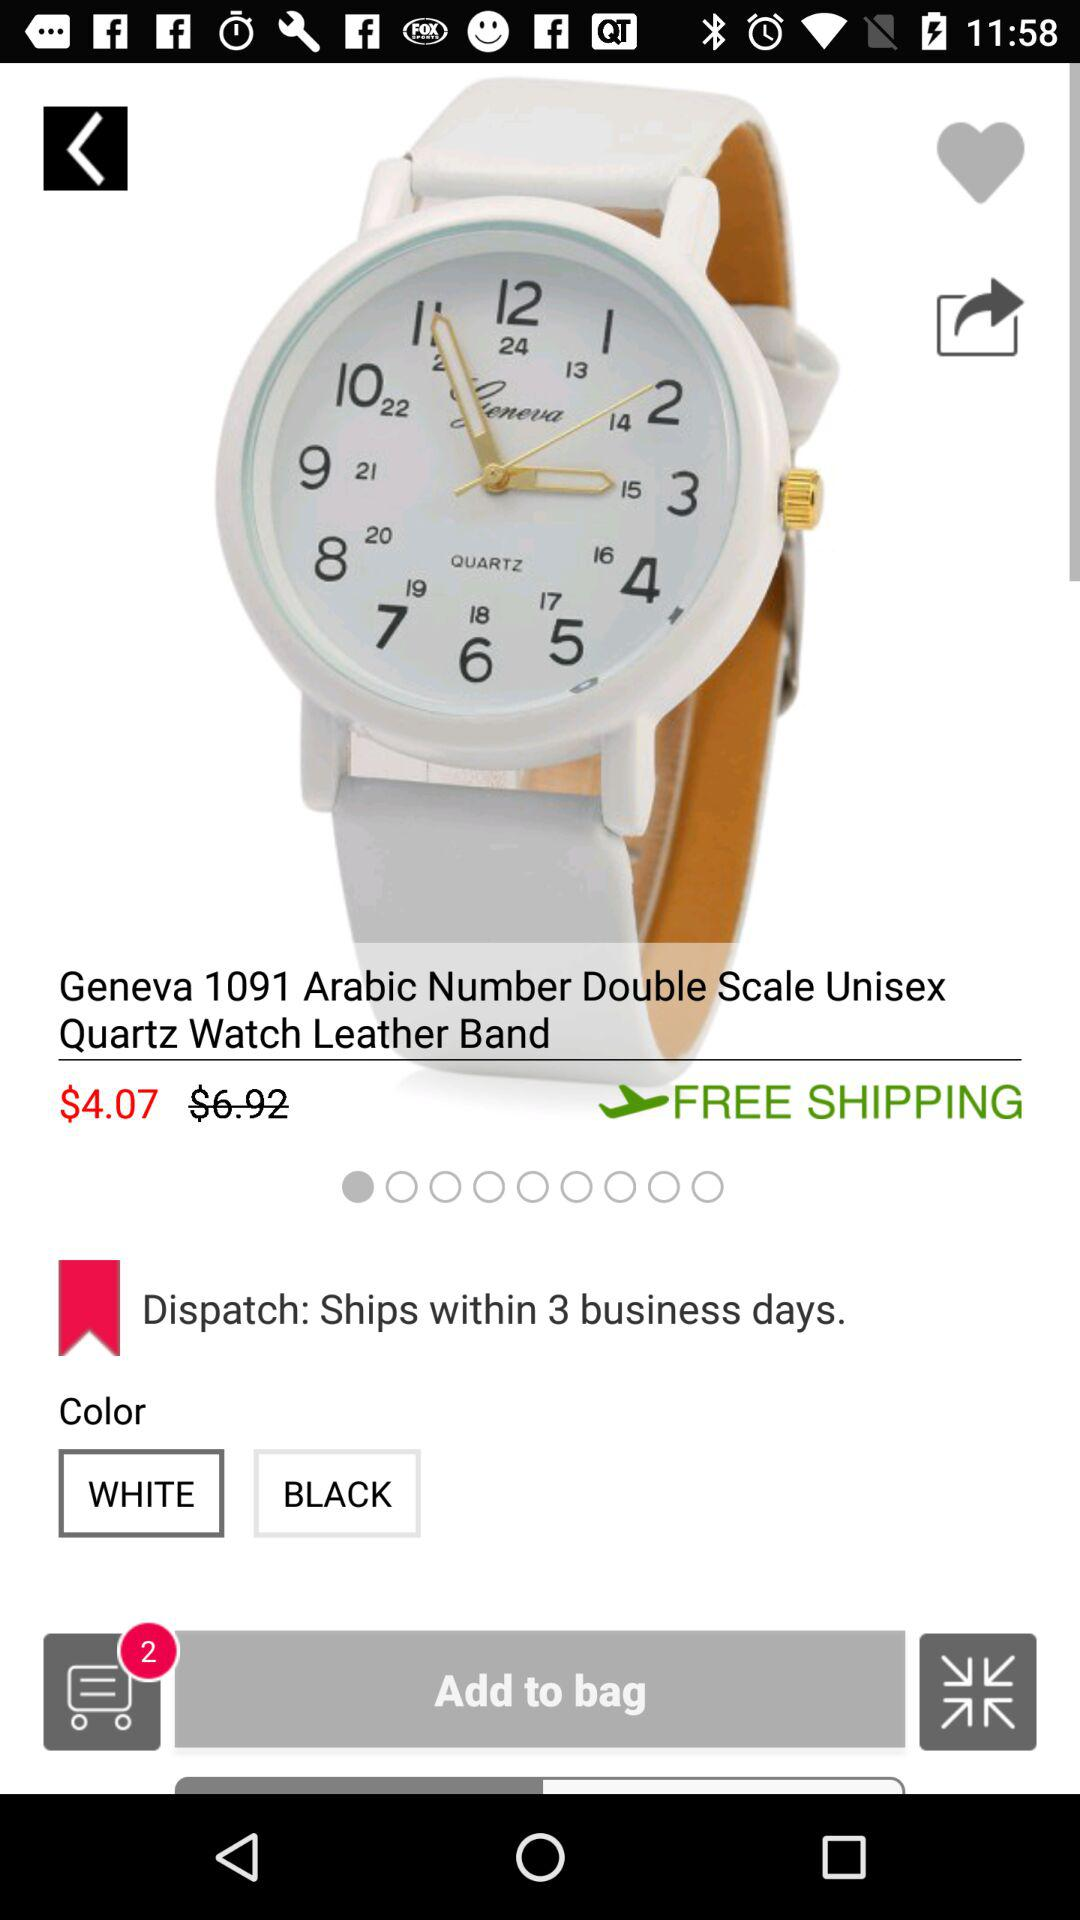Within how many business days will the product be dispatched? The product will be dispatched within 3 business days. 